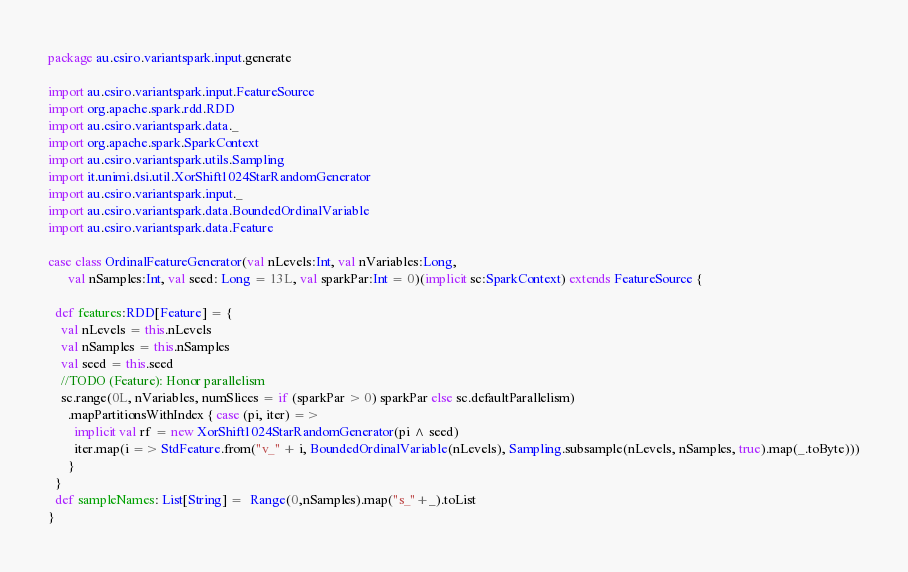Convert code to text. <code><loc_0><loc_0><loc_500><loc_500><_Scala_>package au.csiro.variantspark.input.generate

import au.csiro.variantspark.input.FeatureSource
import org.apache.spark.rdd.RDD
import au.csiro.variantspark.data._
import org.apache.spark.SparkContext
import au.csiro.variantspark.utils.Sampling
import it.unimi.dsi.util.XorShift1024StarRandomGenerator
import au.csiro.variantspark.input._
import au.csiro.variantspark.data.BoundedOrdinalVariable
import au.csiro.variantspark.data.Feature

case class OrdinalFeatureGenerator(val nLevels:Int, val nVariables:Long, 
      val nSamples:Int, val seed: Long = 13L, val sparkPar:Int = 0)(implicit sc:SparkContext) extends FeatureSource {
    
  def features:RDD[Feature] = {
    val nLevels = this.nLevels
    val nSamples = this.nSamples
    val seed = this.seed
    //TODO (Feature): Honor parallelism
    sc.range(0L, nVariables, numSlices = if (sparkPar > 0) sparkPar else sc.defaultParallelism)
      .mapPartitionsWithIndex { case (pi, iter) =>
        implicit val rf = new XorShift1024StarRandomGenerator(pi ^ seed)
        iter.map(i => StdFeature.from("v_" + i, BoundedOrdinalVariable(nLevels), Sampling.subsample(nLevels, nSamples, true).map(_.toByte)))
      }
  }
  def sampleNames: List[String] =  Range(0,nSamples).map("s_"+_).toList  
}
</code> 